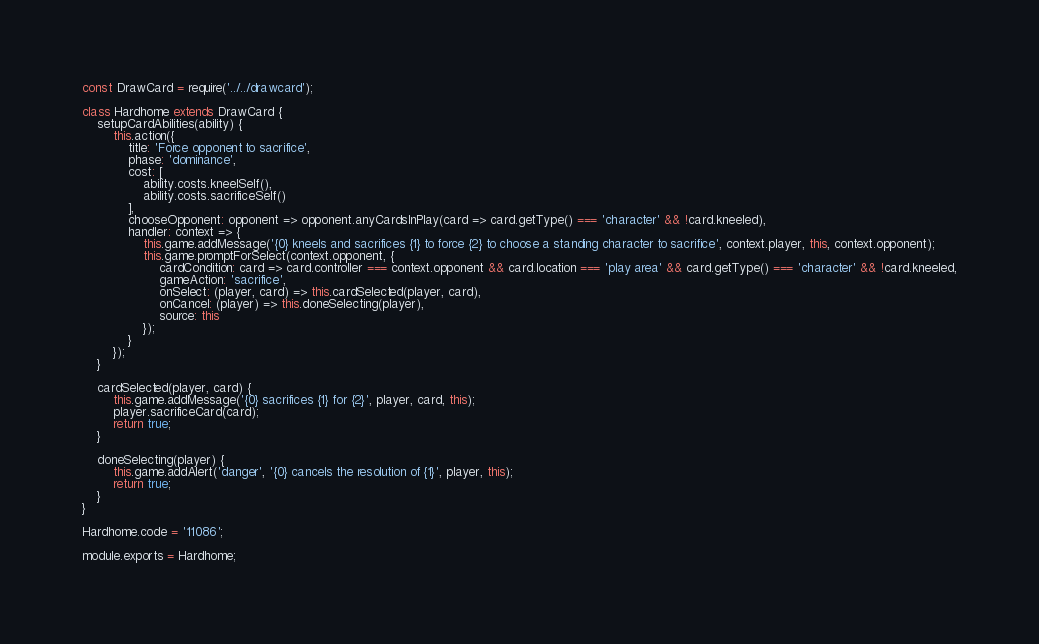Convert code to text. <code><loc_0><loc_0><loc_500><loc_500><_JavaScript_>const DrawCard = require('../../drawcard');

class Hardhome extends DrawCard {
    setupCardAbilities(ability) {
        this.action({
            title: 'Force opponent to sacrifice',
            phase: 'dominance',
            cost: [
                ability.costs.kneelSelf(),
                ability.costs.sacrificeSelf()
            ],
            chooseOpponent: opponent => opponent.anyCardsInPlay(card => card.getType() === 'character' && !card.kneeled),
            handler: context => {
                this.game.addMessage('{0} kneels and sacrifices {1} to force {2} to choose a standing character to sacrifice', context.player, this, context.opponent);
                this.game.promptForSelect(context.opponent, {
                    cardCondition: card => card.controller === context.opponent && card.location === 'play area' && card.getType() === 'character' && !card.kneeled,
                    gameAction: 'sacrifice',
                    onSelect: (player, card) => this.cardSelected(player, card),
                    onCancel: (player) => this.doneSelecting(player),
                    source: this
                });
            }
        });
    }

    cardSelected(player, card) {
        this.game.addMessage('{0} sacrifices {1} for {2}', player, card, this);
        player.sacrificeCard(card);
        return true;
    }

    doneSelecting(player) {
        this.game.addAlert('danger', '{0} cancels the resolution of {1}', player, this);
        return true;
    }
}

Hardhome.code = '11086';

module.exports = Hardhome;
</code> 